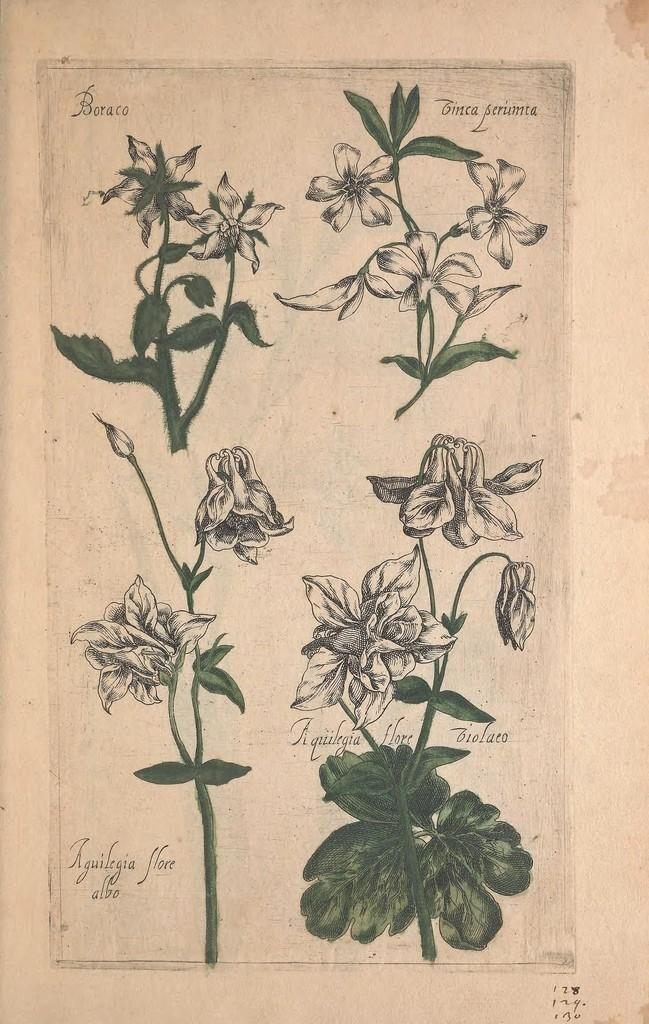What type of artwork might the image be? The image might be a painting on paper. What type of natural elements can be seen in the image? There are plants, leaves, and flowers in the image. How much sugar is present in the image? There is no sugar present in the image, as it features plants, leaves, and flowers. 